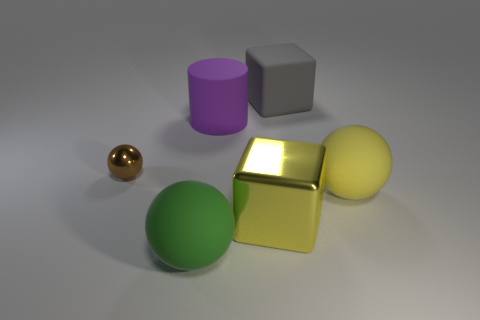What is the shape of the yellow object that is the same material as the small brown thing?
Your response must be concise. Cube. Does the block that is in front of the small brown object have the same material as the large green object?
Ensure brevity in your answer.  No. How many other objects are the same material as the big purple cylinder?
Provide a short and direct response. 3. What number of objects are either large objects in front of the tiny ball or matte things in front of the tiny thing?
Keep it short and to the point. 3. Do the yellow object that is on the right side of the large yellow cube and the yellow thing left of the gray rubber thing have the same shape?
Your answer should be very brief. No. The purple rubber object that is the same size as the yellow metallic thing is what shape?
Your answer should be very brief. Cylinder. How many rubber objects are either large gray balls or purple cylinders?
Keep it short and to the point. 1. Is the material of the large sphere on the right side of the big purple matte thing the same as the large cube that is in front of the small brown metal object?
Keep it short and to the point. No. The large block that is made of the same material as the purple thing is what color?
Provide a short and direct response. Gray. Is the number of yellow objects in front of the metal cube greater than the number of large yellow metal blocks behind the brown sphere?
Your answer should be very brief. No. 